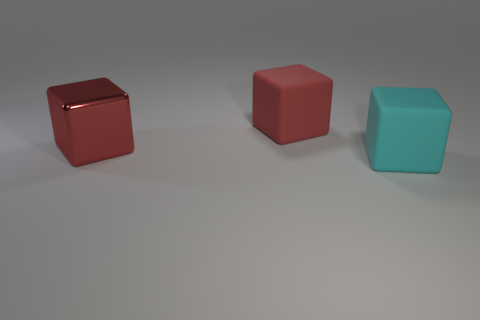Subtract all shiny blocks. How many blocks are left? 2 Add 1 shiny cubes. How many objects exist? 4 Subtract all red cubes. How many cubes are left? 1 Subtract 2 blocks. How many blocks are left? 1 Subtract all gray cylinders. How many red blocks are left? 2 Subtract all matte things. Subtract all tiny green shiny cubes. How many objects are left? 1 Add 3 large cyan matte cubes. How many large cyan matte cubes are left? 4 Add 3 brown matte balls. How many brown matte balls exist? 3 Subtract 0 gray cylinders. How many objects are left? 3 Subtract all gray blocks. Subtract all cyan cylinders. How many blocks are left? 3 